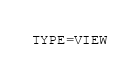<code> <loc_0><loc_0><loc_500><loc_500><_VisualBasic_>TYPE=VIEW</code> 